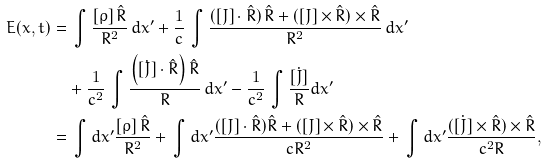<formula> <loc_0><loc_0><loc_500><loc_500>E ( x , t ) & = \, \int \frac { [ \rho ] \, \hat { R } } { R ^ { 2 } } \, d x ^ { \prime } + \frac { 1 } { c } \, \int \frac { ( [ J ] \cdot \hat { R } ) \, \hat { R } + ( [ J ] \times \hat { R } ) \times \hat { R } } { R ^ { 2 } } \, d x ^ { \prime } \\ & \quad + \frac { 1 } { c ^ { 2 } } \, \int \frac { \left ( [ \dot { J } ] \cdot \hat { R } \right ) \hat { R } } { R } \, d { x } ^ { \prime } - \frac { 1 } { c ^ { 2 } } \, \int \frac { [ \dot { J } ] } { R } d { x } ^ { \prime } \\ & = \, \int d x ^ { \prime } \frac { [ \rho ] \, \hat { R } } { R ^ { 2 } } + \, \int d x ^ { \prime } \frac { ( [ J ] \cdot \hat { R } ) \hat { R } + ( [ J ] \times \hat { R } ) \times \hat { R } } { c R ^ { 2 } } + \, \int d x ^ { \prime } \frac { ( \dot { [ J ] } \times \hat { R } ) \times \hat { R } } { c ^ { 2 } R } ,</formula> 